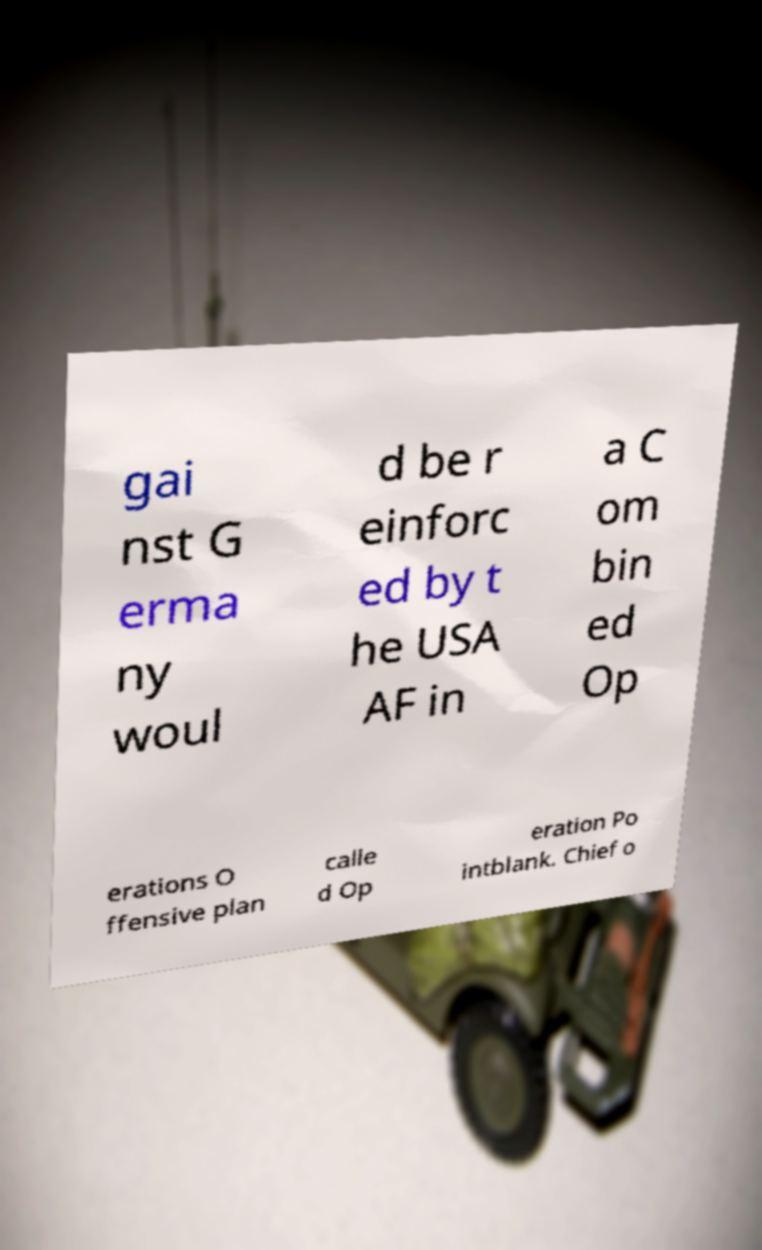For documentation purposes, I need the text within this image transcribed. Could you provide that? gai nst G erma ny woul d be r einforc ed by t he USA AF in a C om bin ed Op erations O ffensive plan calle d Op eration Po intblank. Chief o 